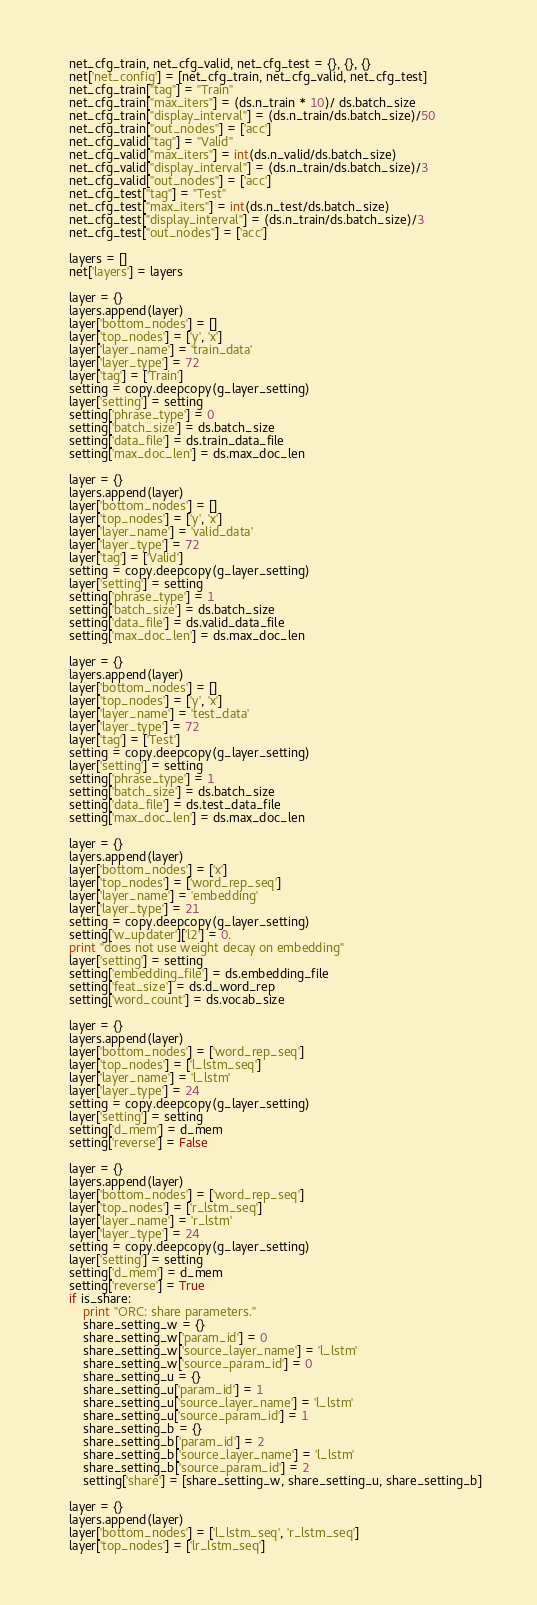Convert code to text. <code><loc_0><loc_0><loc_500><loc_500><_Python_>    net_cfg_train, net_cfg_valid, net_cfg_test = {}, {}, {}
    net['net_config'] = [net_cfg_train, net_cfg_valid, net_cfg_test]
    net_cfg_train["tag"] = "Train"
    net_cfg_train["max_iters"] = (ds.n_train * 10)/ ds.batch_size 
    net_cfg_train["display_interval"] = (ds.n_train/ds.batch_size)/50
    net_cfg_train["out_nodes"] = ['acc']
    net_cfg_valid["tag"] = "Valid"
    net_cfg_valid["max_iters"] = int(ds.n_valid/ds.batch_size) 
    net_cfg_valid["display_interval"] = (ds.n_train/ds.batch_size)/3
    net_cfg_valid["out_nodes"] = ['acc']
    net_cfg_test["tag"] = "Test"
    net_cfg_test["max_iters"] = int(ds.n_test/ds.batch_size) 
    net_cfg_test["display_interval"] = (ds.n_train/ds.batch_size)/3
    net_cfg_test["out_nodes"] = ['acc']
    
    layers = []
    net['layers'] = layers

    layer = {}
    layers.append(layer) 
    layer['bottom_nodes'] = []
    layer['top_nodes'] = ['y', 'x']
    layer['layer_name'] = 'train_data'
    layer['layer_type'] = 72
    layer['tag'] = ['Train']
    setting = copy.deepcopy(g_layer_setting)
    layer['setting'] = setting
    setting['phrase_type'] = 0
    setting['batch_size'] = ds.batch_size
    setting['data_file'] = ds.train_data_file
    setting['max_doc_len'] = ds.max_doc_len

    layer = {}
    layers.append(layer) 
    layer['bottom_nodes'] = []
    layer['top_nodes'] = ['y', 'x']
    layer['layer_name'] = 'valid_data'
    layer['layer_type'] = 72
    layer['tag'] = ['Valid']
    setting = copy.deepcopy(g_layer_setting)
    layer['setting'] = setting
    setting['phrase_type'] = 1
    setting['batch_size'] = ds.batch_size 
    setting['data_file'] = ds.valid_data_file
    setting['max_doc_len'] = ds.max_doc_len

    layer = {}
    layers.append(layer) 
    layer['bottom_nodes'] = []
    layer['top_nodes'] = ['y', 'x']
    layer['layer_name'] = 'test_data'
    layer['layer_type'] = 72
    layer['tag'] = ['Test']
    setting = copy.deepcopy(g_layer_setting)
    layer['setting'] = setting
    setting['phrase_type'] = 1
    setting['batch_size'] = ds.batch_size 
    setting['data_file'] = ds.test_data_file
    setting['max_doc_len'] = ds.max_doc_len

    layer = {}
    layers.append(layer) 
    layer['bottom_nodes'] = ['x']
    layer['top_nodes'] = ['word_rep_seq']
    layer['layer_name'] = 'embedding'
    layer['layer_type'] = 21
    setting = copy.deepcopy(g_layer_setting)
    setting['w_updater']['l2'] = 0.
    print "does not use weight decay on embedding"
    layer['setting'] = setting
    setting['embedding_file'] = ds.embedding_file
    setting['feat_size'] = ds.d_word_rep
    setting['word_count'] = ds.vocab_size

    layer = {}
    layers.append(layer) 
    layer['bottom_nodes'] = ['word_rep_seq']
    layer['top_nodes'] = ['l_lstm_seq']
    layer['layer_name'] = 'l_lstm'
    layer['layer_type'] = 24
    setting = copy.deepcopy(g_layer_setting)
    layer['setting'] = setting
    setting['d_mem'] = d_mem
    setting['reverse'] = False

    layer = {}
    layers.append(layer) 
    layer['bottom_nodes'] = ['word_rep_seq']
    layer['top_nodes'] = ['r_lstm_seq']
    layer['layer_name'] = 'r_lstm'
    layer['layer_type'] = 24
    setting = copy.deepcopy(g_layer_setting)
    layer['setting'] = setting
    setting['d_mem'] = d_mem
    setting['reverse'] = True 
    if is_share:
        print "ORC: share parameters."
        share_setting_w = {}
        share_setting_w['param_id'] = 0
        share_setting_w['source_layer_name'] = 'l_lstm'
        share_setting_w['source_param_id'] = 0
        share_setting_u = {}
        share_setting_u['param_id'] = 1
        share_setting_u['source_layer_name'] = 'l_lstm'
        share_setting_u['source_param_id'] = 1
        share_setting_b = {}
        share_setting_b['param_id'] = 2
        share_setting_b['source_layer_name'] = 'l_lstm'
        share_setting_b['source_param_id'] = 2
        setting['share'] = [share_setting_w, share_setting_u, share_setting_b]

    layer = {}
    layers.append(layer) 
    layer['bottom_nodes'] = ['l_lstm_seq', 'r_lstm_seq']
    layer['top_nodes'] = ['lr_lstm_seq']</code> 